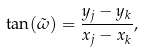<formula> <loc_0><loc_0><loc_500><loc_500>\tan ( \tilde { \omega } ) = \frac { y _ { j } - y _ { k } } { x _ { j } - x _ { k } } ,</formula> 